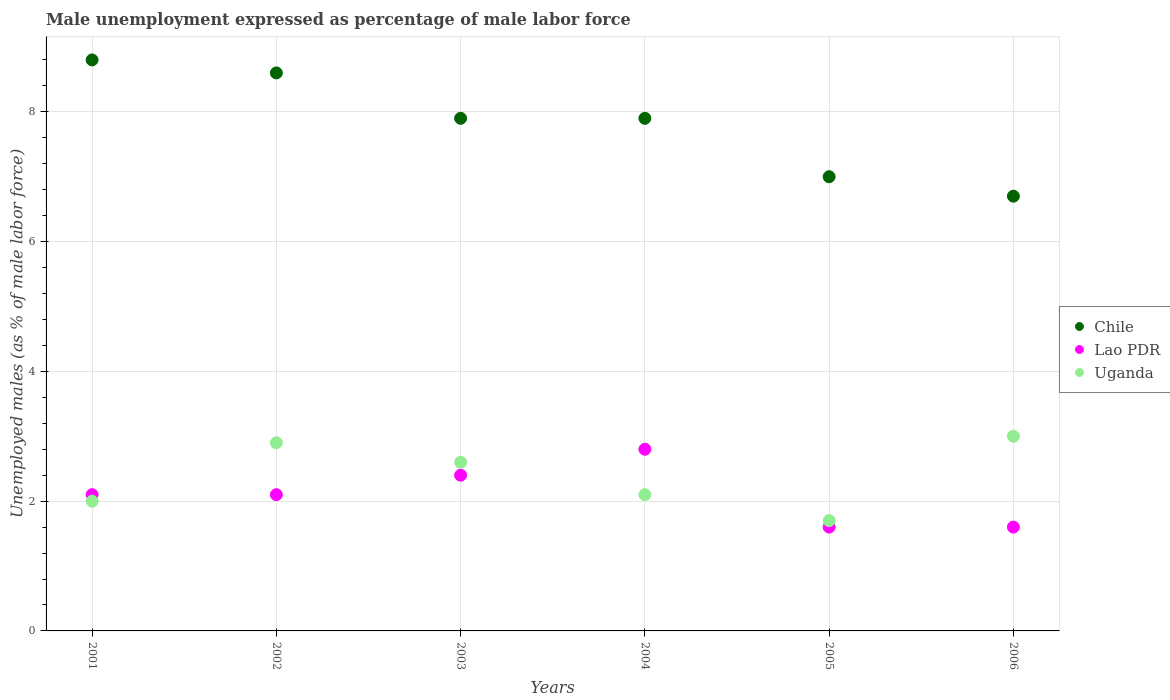How many different coloured dotlines are there?
Provide a short and direct response. 3. What is the unemployment in males in in Uganda in 2006?
Your answer should be very brief. 3. Across all years, what is the maximum unemployment in males in in Lao PDR?
Your answer should be very brief. 2.8. Across all years, what is the minimum unemployment in males in in Chile?
Provide a succinct answer. 6.7. In which year was the unemployment in males in in Lao PDR maximum?
Give a very brief answer. 2004. What is the total unemployment in males in in Lao PDR in the graph?
Your response must be concise. 12.6. What is the difference between the unemployment in males in in Chile in 2004 and the unemployment in males in in Uganda in 2003?
Keep it short and to the point. 5.3. What is the average unemployment in males in in Chile per year?
Your answer should be compact. 7.82. In the year 2003, what is the difference between the unemployment in males in in Chile and unemployment in males in in Uganda?
Give a very brief answer. 5.3. What is the ratio of the unemployment in males in in Lao PDR in 2001 to that in 2004?
Make the answer very short. 0.75. Is the unemployment in males in in Chile in 2004 less than that in 2006?
Make the answer very short. No. What is the difference between the highest and the second highest unemployment in males in in Lao PDR?
Your answer should be compact. 0.4. What is the difference between the highest and the lowest unemployment in males in in Uganda?
Make the answer very short. 1.3. Is the sum of the unemployment in males in in Uganda in 2001 and 2006 greater than the maximum unemployment in males in in Lao PDR across all years?
Keep it short and to the point. Yes. Is it the case that in every year, the sum of the unemployment in males in in Chile and unemployment in males in in Lao PDR  is greater than the unemployment in males in in Uganda?
Offer a terse response. Yes. Does the unemployment in males in in Chile monotonically increase over the years?
Your response must be concise. No. Is the unemployment in males in in Uganda strictly less than the unemployment in males in in Chile over the years?
Your answer should be compact. Yes. How many dotlines are there?
Offer a terse response. 3. How many years are there in the graph?
Make the answer very short. 6. Are the values on the major ticks of Y-axis written in scientific E-notation?
Ensure brevity in your answer.  No. Does the graph contain grids?
Make the answer very short. Yes. Where does the legend appear in the graph?
Provide a succinct answer. Center right. How many legend labels are there?
Your response must be concise. 3. What is the title of the graph?
Offer a terse response. Male unemployment expressed as percentage of male labor force. Does "Comoros" appear as one of the legend labels in the graph?
Provide a short and direct response. No. What is the label or title of the Y-axis?
Ensure brevity in your answer.  Unemployed males (as % of male labor force). What is the Unemployed males (as % of male labor force) in Chile in 2001?
Keep it short and to the point. 8.8. What is the Unemployed males (as % of male labor force) of Lao PDR in 2001?
Offer a very short reply. 2.1. What is the Unemployed males (as % of male labor force) of Chile in 2002?
Offer a very short reply. 8.6. What is the Unemployed males (as % of male labor force) in Lao PDR in 2002?
Make the answer very short. 2.1. What is the Unemployed males (as % of male labor force) of Uganda in 2002?
Ensure brevity in your answer.  2.9. What is the Unemployed males (as % of male labor force) in Chile in 2003?
Your response must be concise. 7.9. What is the Unemployed males (as % of male labor force) in Lao PDR in 2003?
Offer a very short reply. 2.4. What is the Unemployed males (as % of male labor force) in Uganda in 2003?
Provide a short and direct response. 2.6. What is the Unemployed males (as % of male labor force) of Chile in 2004?
Offer a terse response. 7.9. What is the Unemployed males (as % of male labor force) of Lao PDR in 2004?
Your answer should be compact. 2.8. What is the Unemployed males (as % of male labor force) of Uganda in 2004?
Keep it short and to the point. 2.1. What is the Unemployed males (as % of male labor force) of Chile in 2005?
Provide a short and direct response. 7. What is the Unemployed males (as % of male labor force) of Lao PDR in 2005?
Offer a terse response. 1.6. What is the Unemployed males (as % of male labor force) in Uganda in 2005?
Your answer should be very brief. 1.7. What is the Unemployed males (as % of male labor force) in Chile in 2006?
Offer a terse response. 6.7. What is the Unemployed males (as % of male labor force) in Lao PDR in 2006?
Provide a short and direct response. 1.6. What is the Unemployed males (as % of male labor force) in Uganda in 2006?
Give a very brief answer. 3. Across all years, what is the maximum Unemployed males (as % of male labor force) of Chile?
Make the answer very short. 8.8. Across all years, what is the maximum Unemployed males (as % of male labor force) in Lao PDR?
Provide a succinct answer. 2.8. Across all years, what is the minimum Unemployed males (as % of male labor force) in Chile?
Your answer should be very brief. 6.7. Across all years, what is the minimum Unemployed males (as % of male labor force) in Lao PDR?
Provide a short and direct response. 1.6. Across all years, what is the minimum Unemployed males (as % of male labor force) of Uganda?
Your response must be concise. 1.7. What is the total Unemployed males (as % of male labor force) in Chile in the graph?
Your answer should be very brief. 46.9. What is the difference between the Unemployed males (as % of male labor force) in Chile in 2001 and that in 2002?
Provide a succinct answer. 0.2. What is the difference between the Unemployed males (as % of male labor force) of Lao PDR in 2001 and that in 2002?
Ensure brevity in your answer.  0. What is the difference between the Unemployed males (as % of male labor force) in Uganda in 2001 and that in 2002?
Give a very brief answer. -0.9. What is the difference between the Unemployed males (as % of male labor force) in Chile in 2001 and that in 2003?
Offer a very short reply. 0.9. What is the difference between the Unemployed males (as % of male labor force) in Lao PDR in 2001 and that in 2003?
Give a very brief answer. -0.3. What is the difference between the Unemployed males (as % of male labor force) of Uganda in 2001 and that in 2003?
Give a very brief answer. -0.6. What is the difference between the Unemployed males (as % of male labor force) in Uganda in 2001 and that in 2004?
Ensure brevity in your answer.  -0.1. What is the difference between the Unemployed males (as % of male labor force) of Chile in 2001 and that in 2005?
Your answer should be compact. 1.8. What is the difference between the Unemployed males (as % of male labor force) in Lao PDR in 2001 and that in 2005?
Keep it short and to the point. 0.5. What is the difference between the Unemployed males (as % of male labor force) in Chile in 2001 and that in 2006?
Provide a succinct answer. 2.1. What is the difference between the Unemployed males (as % of male labor force) of Uganda in 2001 and that in 2006?
Your answer should be compact. -1. What is the difference between the Unemployed males (as % of male labor force) in Lao PDR in 2002 and that in 2003?
Make the answer very short. -0.3. What is the difference between the Unemployed males (as % of male labor force) of Uganda in 2002 and that in 2003?
Offer a terse response. 0.3. What is the difference between the Unemployed males (as % of male labor force) in Chile in 2002 and that in 2005?
Provide a short and direct response. 1.6. What is the difference between the Unemployed males (as % of male labor force) in Lao PDR in 2002 and that in 2005?
Provide a succinct answer. 0.5. What is the difference between the Unemployed males (as % of male labor force) in Uganda in 2002 and that in 2005?
Provide a short and direct response. 1.2. What is the difference between the Unemployed males (as % of male labor force) in Lao PDR in 2002 and that in 2006?
Provide a succinct answer. 0.5. What is the difference between the Unemployed males (as % of male labor force) of Uganda in 2003 and that in 2004?
Make the answer very short. 0.5. What is the difference between the Unemployed males (as % of male labor force) in Chile in 2003 and that in 2006?
Give a very brief answer. 1.2. What is the difference between the Unemployed males (as % of male labor force) in Lao PDR in 2003 and that in 2006?
Offer a very short reply. 0.8. What is the difference between the Unemployed males (as % of male labor force) in Uganda in 2003 and that in 2006?
Your answer should be compact. -0.4. What is the difference between the Unemployed males (as % of male labor force) of Uganda in 2004 and that in 2005?
Your answer should be compact. 0.4. What is the difference between the Unemployed males (as % of male labor force) in Chile in 2004 and that in 2006?
Your answer should be very brief. 1.2. What is the difference between the Unemployed males (as % of male labor force) in Uganda in 2004 and that in 2006?
Keep it short and to the point. -0.9. What is the difference between the Unemployed males (as % of male labor force) in Lao PDR in 2005 and that in 2006?
Provide a succinct answer. 0. What is the difference between the Unemployed males (as % of male labor force) of Chile in 2001 and the Unemployed males (as % of male labor force) of Lao PDR in 2002?
Your response must be concise. 6.7. What is the difference between the Unemployed males (as % of male labor force) of Chile in 2001 and the Unemployed males (as % of male labor force) of Uganda in 2002?
Offer a terse response. 5.9. What is the difference between the Unemployed males (as % of male labor force) of Chile in 2001 and the Unemployed males (as % of male labor force) of Lao PDR in 2003?
Your response must be concise. 6.4. What is the difference between the Unemployed males (as % of male labor force) in Chile in 2001 and the Unemployed males (as % of male labor force) in Uganda in 2004?
Provide a succinct answer. 6.7. What is the difference between the Unemployed males (as % of male labor force) in Chile in 2001 and the Unemployed males (as % of male labor force) in Uganda in 2005?
Provide a short and direct response. 7.1. What is the difference between the Unemployed males (as % of male labor force) in Chile in 2001 and the Unemployed males (as % of male labor force) in Lao PDR in 2006?
Keep it short and to the point. 7.2. What is the difference between the Unemployed males (as % of male labor force) in Lao PDR in 2001 and the Unemployed males (as % of male labor force) in Uganda in 2006?
Provide a succinct answer. -0.9. What is the difference between the Unemployed males (as % of male labor force) of Chile in 2002 and the Unemployed males (as % of male labor force) of Uganda in 2003?
Provide a short and direct response. 6. What is the difference between the Unemployed males (as % of male labor force) of Lao PDR in 2002 and the Unemployed males (as % of male labor force) of Uganda in 2004?
Ensure brevity in your answer.  0. What is the difference between the Unemployed males (as % of male labor force) of Chile in 2002 and the Unemployed males (as % of male labor force) of Uganda in 2005?
Provide a succinct answer. 6.9. What is the difference between the Unemployed males (as % of male labor force) in Chile in 2002 and the Unemployed males (as % of male labor force) in Uganda in 2006?
Your answer should be compact. 5.6. What is the difference between the Unemployed males (as % of male labor force) of Chile in 2003 and the Unemployed males (as % of male labor force) of Lao PDR in 2004?
Your answer should be very brief. 5.1. What is the difference between the Unemployed males (as % of male labor force) in Chile in 2003 and the Unemployed males (as % of male labor force) in Uganda in 2004?
Keep it short and to the point. 5.8. What is the difference between the Unemployed males (as % of male labor force) of Lao PDR in 2003 and the Unemployed males (as % of male labor force) of Uganda in 2005?
Provide a succinct answer. 0.7. What is the difference between the Unemployed males (as % of male labor force) in Chile in 2003 and the Unemployed males (as % of male labor force) in Lao PDR in 2006?
Your response must be concise. 6.3. What is the difference between the Unemployed males (as % of male labor force) of Chile in 2003 and the Unemployed males (as % of male labor force) of Uganda in 2006?
Give a very brief answer. 4.9. What is the difference between the Unemployed males (as % of male labor force) of Chile in 2004 and the Unemployed males (as % of male labor force) of Uganda in 2005?
Make the answer very short. 6.2. What is the difference between the Unemployed males (as % of male labor force) in Lao PDR in 2004 and the Unemployed males (as % of male labor force) in Uganda in 2005?
Your response must be concise. 1.1. What is the difference between the Unemployed males (as % of male labor force) in Chile in 2004 and the Unemployed males (as % of male labor force) in Lao PDR in 2006?
Keep it short and to the point. 6.3. What is the difference between the Unemployed males (as % of male labor force) in Lao PDR in 2004 and the Unemployed males (as % of male labor force) in Uganda in 2006?
Make the answer very short. -0.2. What is the difference between the Unemployed males (as % of male labor force) in Lao PDR in 2005 and the Unemployed males (as % of male labor force) in Uganda in 2006?
Your response must be concise. -1.4. What is the average Unemployed males (as % of male labor force) of Chile per year?
Make the answer very short. 7.82. What is the average Unemployed males (as % of male labor force) of Lao PDR per year?
Your response must be concise. 2.1. What is the average Unemployed males (as % of male labor force) of Uganda per year?
Make the answer very short. 2.38. In the year 2001, what is the difference between the Unemployed males (as % of male labor force) in Chile and Unemployed males (as % of male labor force) in Lao PDR?
Provide a succinct answer. 6.7. In the year 2002, what is the difference between the Unemployed males (as % of male labor force) in Chile and Unemployed males (as % of male labor force) in Uganda?
Give a very brief answer. 5.7. In the year 2002, what is the difference between the Unemployed males (as % of male labor force) of Lao PDR and Unemployed males (as % of male labor force) of Uganda?
Your answer should be very brief. -0.8. In the year 2004, what is the difference between the Unemployed males (as % of male labor force) in Chile and Unemployed males (as % of male labor force) in Uganda?
Offer a very short reply. 5.8. In the year 2004, what is the difference between the Unemployed males (as % of male labor force) of Lao PDR and Unemployed males (as % of male labor force) of Uganda?
Your answer should be very brief. 0.7. In the year 2005, what is the difference between the Unemployed males (as % of male labor force) in Chile and Unemployed males (as % of male labor force) in Uganda?
Your response must be concise. 5.3. In the year 2005, what is the difference between the Unemployed males (as % of male labor force) of Lao PDR and Unemployed males (as % of male labor force) of Uganda?
Give a very brief answer. -0.1. In the year 2006, what is the difference between the Unemployed males (as % of male labor force) of Chile and Unemployed males (as % of male labor force) of Lao PDR?
Ensure brevity in your answer.  5.1. In the year 2006, what is the difference between the Unemployed males (as % of male labor force) of Chile and Unemployed males (as % of male labor force) of Uganda?
Your answer should be compact. 3.7. In the year 2006, what is the difference between the Unemployed males (as % of male labor force) in Lao PDR and Unemployed males (as % of male labor force) in Uganda?
Provide a short and direct response. -1.4. What is the ratio of the Unemployed males (as % of male labor force) of Chile in 2001 to that in 2002?
Give a very brief answer. 1.02. What is the ratio of the Unemployed males (as % of male labor force) in Uganda in 2001 to that in 2002?
Provide a short and direct response. 0.69. What is the ratio of the Unemployed males (as % of male labor force) in Chile in 2001 to that in 2003?
Your answer should be compact. 1.11. What is the ratio of the Unemployed males (as % of male labor force) of Lao PDR in 2001 to that in 2003?
Keep it short and to the point. 0.88. What is the ratio of the Unemployed males (as % of male labor force) of Uganda in 2001 to that in 2003?
Keep it short and to the point. 0.77. What is the ratio of the Unemployed males (as % of male labor force) in Chile in 2001 to that in 2004?
Your answer should be very brief. 1.11. What is the ratio of the Unemployed males (as % of male labor force) of Lao PDR in 2001 to that in 2004?
Keep it short and to the point. 0.75. What is the ratio of the Unemployed males (as % of male labor force) of Chile in 2001 to that in 2005?
Offer a terse response. 1.26. What is the ratio of the Unemployed males (as % of male labor force) in Lao PDR in 2001 to that in 2005?
Offer a very short reply. 1.31. What is the ratio of the Unemployed males (as % of male labor force) in Uganda in 2001 to that in 2005?
Give a very brief answer. 1.18. What is the ratio of the Unemployed males (as % of male labor force) in Chile in 2001 to that in 2006?
Offer a very short reply. 1.31. What is the ratio of the Unemployed males (as % of male labor force) of Lao PDR in 2001 to that in 2006?
Offer a terse response. 1.31. What is the ratio of the Unemployed males (as % of male labor force) of Chile in 2002 to that in 2003?
Give a very brief answer. 1.09. What is the ratio of the Unemployed males (as % of male labor force) of Lao PDR in 2002 to that in 2003?
Offer a terse response. 0.88. What is the ratio of the Unemployed males (as % of male labor force) in Uganda in 2002 to that in 2003?
Offer a terse response. 1.12. What is the ratio of the Unemployed males (as % of male labor force) in Chile in 2002 to that in 2004?
Make the answer very short. 1.09. What is the ratio of the Unemployed males (as % of male labor force) of Lao PDR in 2002 to that in 2004?
Ensure brevity in your answer.  0.75. What is the ratio of the Unemployed males (as % of male labor force) in Uganda in 2002 to that in 2004?
Provide a succinct answer. 1.38. What is the ratio of the Unemployed males (as % of male labor force) of Chile in 2002 to that in 2005?
Provide a short and direct response. 1.23. What is the ratio of the Unemployed males (as % of male labor force) of Lao PDR in 2002 to that in 2005?
Offer a very short reply. 1.31. What is the ratio of the Unemployed males (as % of male labor force) in Uganda in 2002 to that in 2005?
Your answer should be compact. 1.71. What is the ratio of the Unemployed males (as % of male labor force) in Chile in 2002 to that in 2006?
Keep it short and to the point. 1.28. What is the ratio of the Unemployed males (as % of male labor force) in Lao PDR in 2002 to that in 2006?
Your answer should be very brief. 1.31. What is the ratio of the Unemployed males (as % of male labor force) in Uganda in 2002 to that in 2006?
Make the answer very short. 0.97. What is the ratio of the Unemployed males (as % of male labor force) of Chile in 2003 to that in 2004?
Your answer should be very brief. 1. What is the ratio of the Unemployed males (as % of male labor force) in Uganda in 2003 to that in 2004?
Provide a succinct answer. 1.24. What is the ratio of the Unemployed males (as % of male labor force) of Chile in 2003 to that in 2005?
Ensure brevity in your answer.  1.13. What is the ratio of the Unemployed males (as % of male labor force) of Lao PDR in 2003 to that in 2005?
Provide a succinct answer. 1.5. What is the ratio of the Unemployed males (as % of male labor force) in Uganda in 2003 to that in 2005?
Provide a short and direct response. 1.53. What is the ratio of the Unemployed males (as % of male labor force) in Chile in 2003 to that in 2006?
Your answer should be very brief. 1.18. What is the ratio of the Unemployed males (as % of male labor force) of Lao PDR in 2003 to that in 2006?
Make the answer very short. 1.5. What is the ratio of the Unemployed males (as % of male labor force) in Uganda in 2003 to that in 2006?
Your answer should be very brief. 0.87. What is the ratio of the Unemployed males (as % of male labor force) of Chile in 2004 to that in 2005?
Your response must be concise. 1.13. What is the ratio of the Unemployed males (as % of male labor force) in Uganda in 2004 to that in 2005?
Give a very brief answer. 1.24. What is the ratio of the Unemployed males (as % of male labor force) in Chile in 2004 to that in 2006?
Give a very brief answer. 1.18. What is the ratio of the Unemployed males (as % of male labor force) in Lao PDR in 2004 to that in 2006?
Provide a succinct answer. 1.75. What is the ratio of the Unemployed males (as % of male labor force) in Uganda in 2004 to that in 2006?
Offer a terse response. 0.7. What is the ratio of the Unemployed males (as % of male labor force) of Chile in 2005 to that in 2006?
Provide a succinct answer. 1.04. What is the ratio of the Unemployed males (as % of male labor force) of Uganda in 2005 to that in 2006?
Your answer should be very brief. 0.57. What is the difference between the highest and the second highest Unemployed males (as % of male labor force) of Lao PDR?
Keep it short and to the point. 0.4. What is the difference between the highest and the second highest Unemployed males (as % of male labor force) in Uganda?
Offer a terse response. 0.1. What is the difference between the highest and the lowest Unemployed males (as % of male labor force) of Uganda?
Provide a succinct answer. 1.3. 